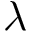<formula> <loc_0><loc_0><loc_500><loc_500>\lambda</formula> 